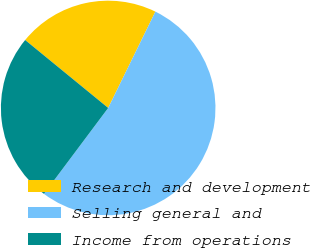Convert chart to OTSL. <chart><loc_0><loc_0><loc_500><loc_500><pie_chart><fcel>Research and development<fcel>Selling general and<fcel>Income from operations<nl><fcel>21.34%<fcel>52.96%<fcel>25.69%<nl></chart> 